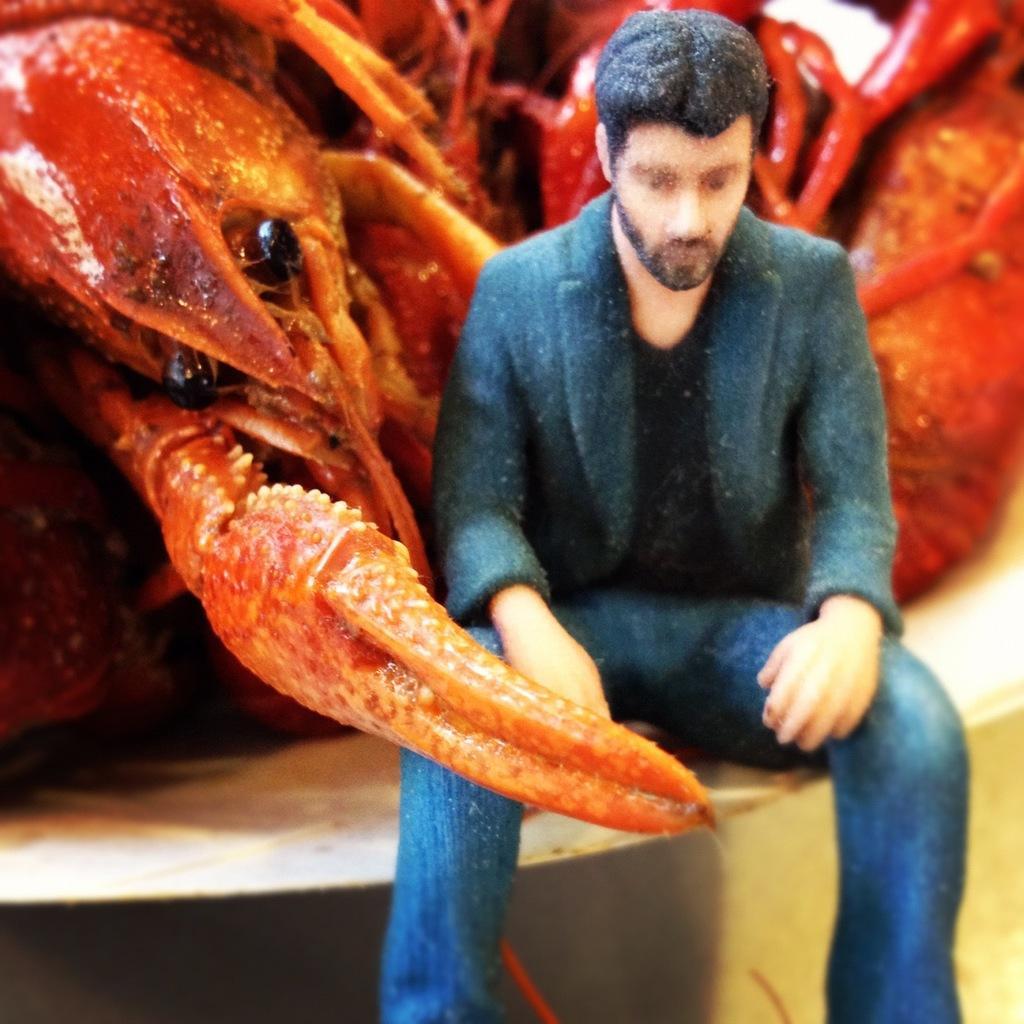Could you give a brief overview of what you see in this image? In this image we can see a person sitting, behind him, we can see a crab. 